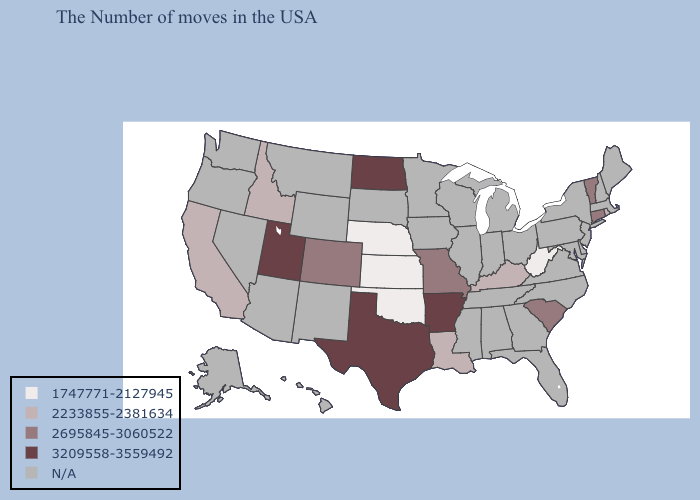Which states have the lowest value in the South?
Give a very brief answer. West Virginia, Oklahoma. Name the states that have a value in the range 2695845-3060522?
Keep it brief. Vermont, Connecticut, South Carolina, Missouri, Colorado. Among the states that border Iowa , which have the highest value?
Be succinct. Missouri. Does the map have missing data?
Be succinct. Yes. Name the states that have a value in the range 2233855-2381634?
Short answer required. Rhode Island, Kentucky, Louisiana, Idaho, California. What is the lowest value in the USA?
Concise answer only. 1747771-2127945. What is the value of Rhode Island?
Answer briefly. 2233855-2381634. What is the lowest value in the USA?
Short answer required. 1747771-2127945. Name the states that have a value in the range 2233855-2381634?
Concise answer only. Rhode Island, Kentucky, Louisiana, Idaho, California. What is the highest value in the Northeast ?
Give a very brief answer. 2695845-3060522. What is the lowest value in the South?
Quick response, please. 1747771-2127945. Name the states that have a value in the range 2233855-2381634?
Write a very short answer. Rhode Island, Kentucky, Louisiana, Idaho, California. Does the map have missing data?
Give a very brief answer. Yes. 